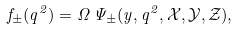Convert formula to latex. <formula><loc_0><loc_0><loc_500><loc_500>f _ { \pm } ( q ^ { 2 } ) = \Omega \, \Psi _ { \pm } ( y , q ^ { 2 } , \mathcal { X } , \mathcal { Y } , \mathcal { Z } ) ,</formula> 